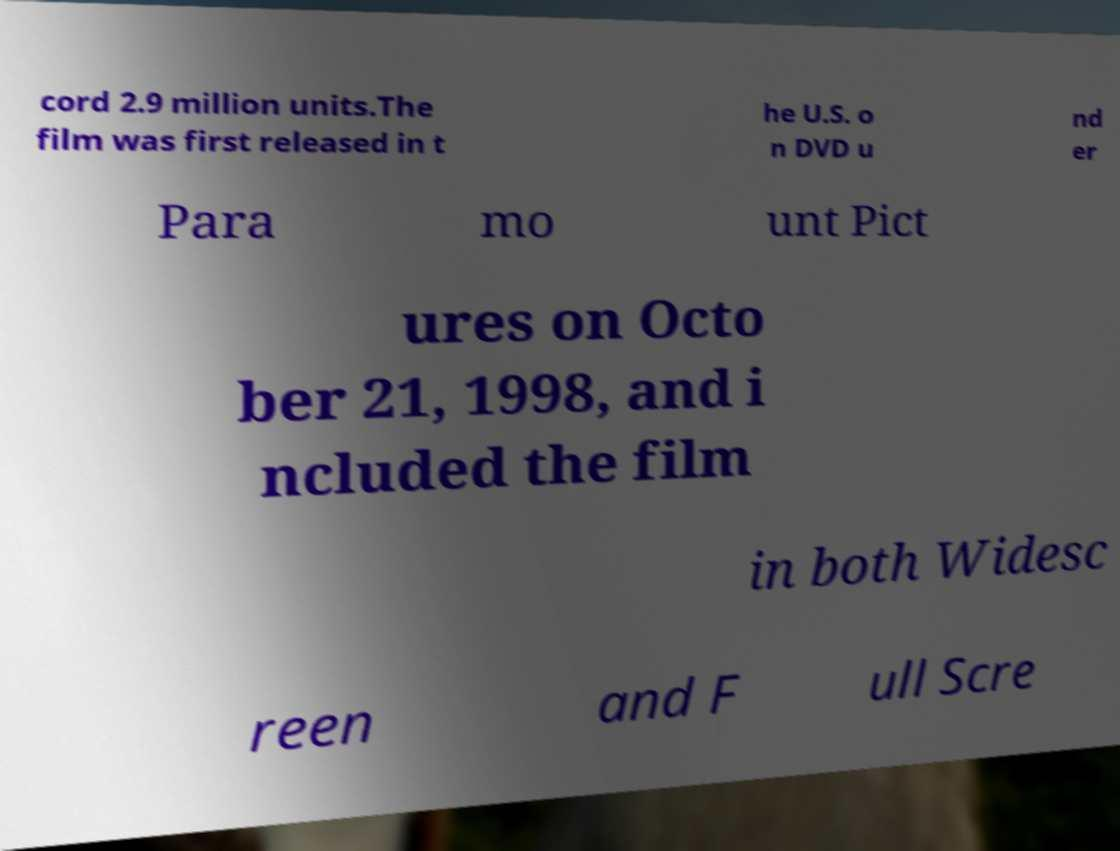Please identify and transcribe the text found in this image. cord 2.9 million units.The film was first released in t he U.S. o n DVD u nd er Para mo unt Pict ures on Octo ber 21, 1998, and i ncluded the film in both Widesc reen and F ull Scre 